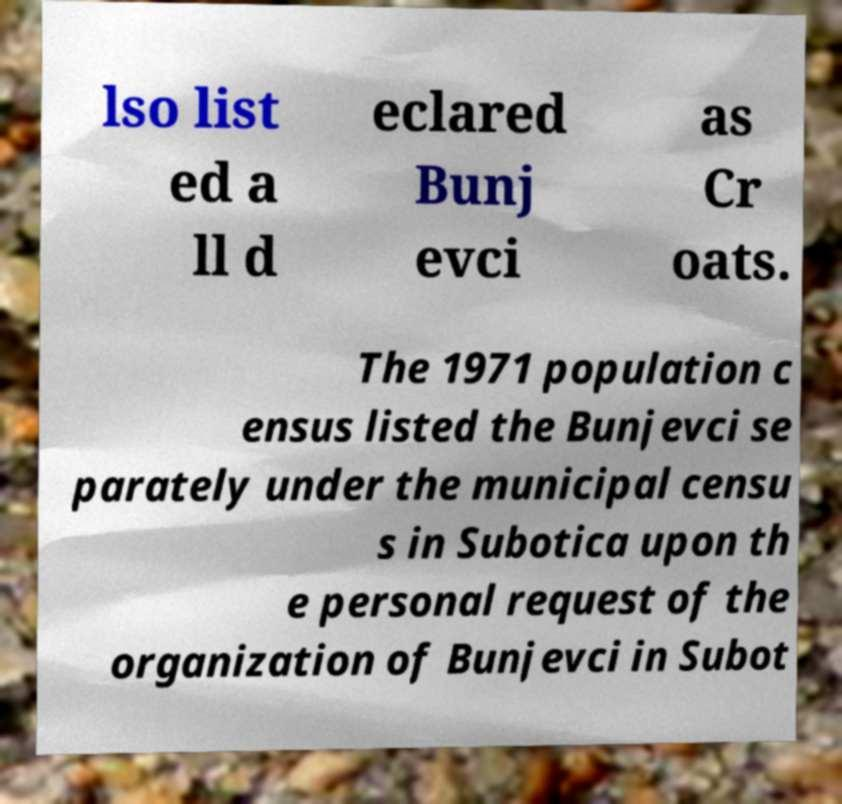Could you assist in decoding the text presented in this image and type it out clearly? lso list ed a ll d eclared Bunj evci as Cr oats. The 1971 population c ensus listed the Bunjevci se parately under the municipal censu s in Subotica upon th e personal request of the organization of Bunjevci in Subot 